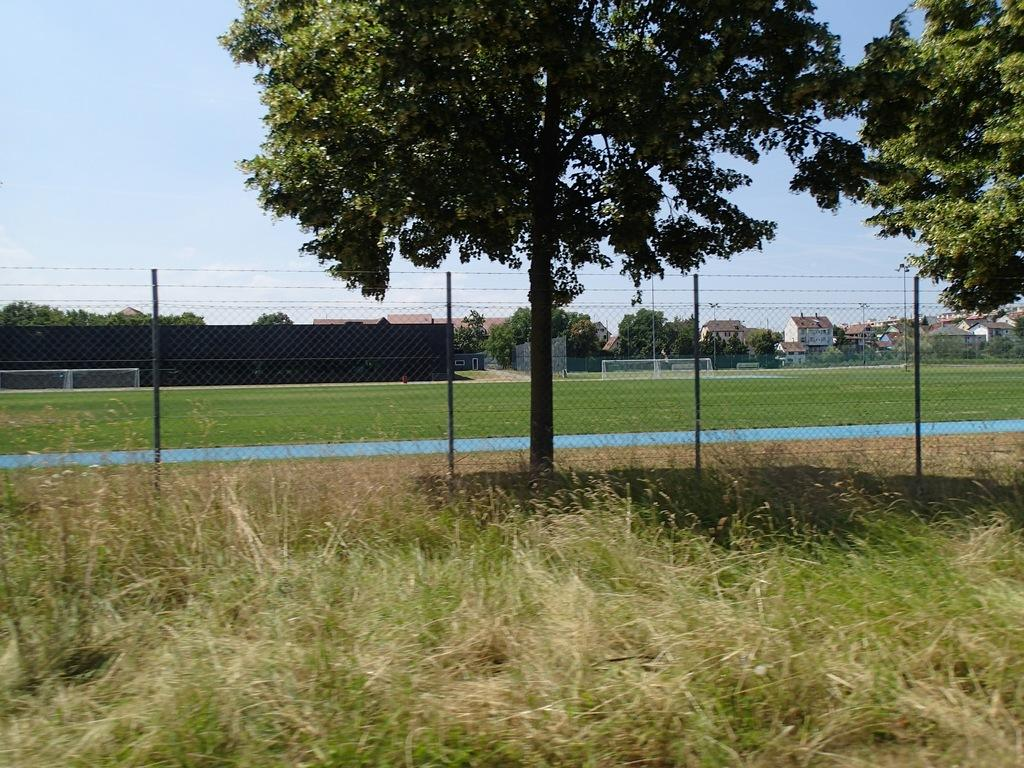What is the main object in the foreground of the image? There is a fencing net in the image. What type of natural environment is visible in the image? There are trees and grass on the ground in the image. What structures can be seen in the background of the image? There are houses visible in the background of the image. What is visible at the top of the image? The sky is visible at the top of the image. Can you tell me what type of wrench is being used in the argument in the image? There is no wrench or argument present in the image. What religious belief is depicted in the image? There is no religious belief depicted in the image; it features a fencing net, trees, grass, houses, and the sky. 